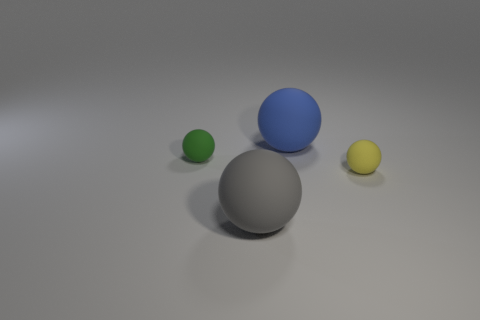Subtract all gray spheres. How many spheres are left? 3 Subtract all yellow balls. How many balls are left? 3 Add 3 large blue balls. How many objects exist? 7 Subtract 1 spheres. How many spheres are left? 3 Subtract all large objects. Subtract all gray things. How many objects are left? 1 Add 2 yellow rubber things. How many yellow rubber things are left? 3 Add 3 small gray metal spheres. How many small gray metal spheres exist? 3 Subtract 0 red cubes. How many objects are left? 4 Subtract all brown spheres. Subtract all cyan blocks. How many spheres are left? 4 Subtract all gray cubes. How many purple balls are left? 0 